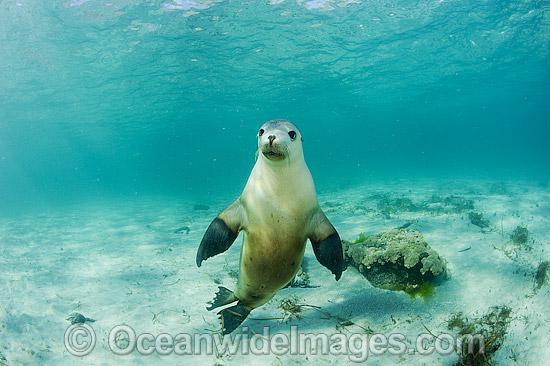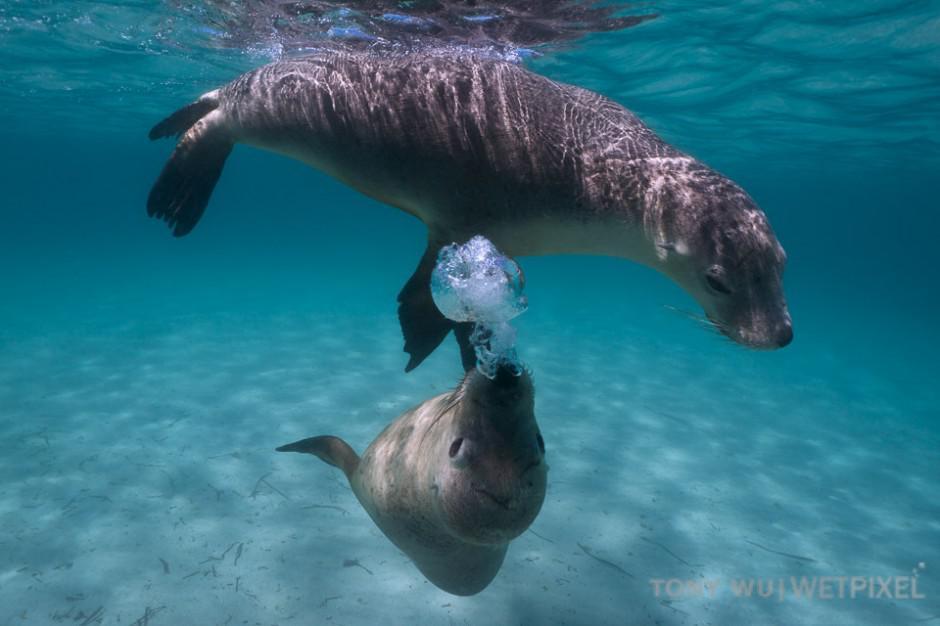The first image is the image on the left, the second image is the image on the right. Analyze the images presented: Is the assertion "None of the images have more than two seals." valid? Answer yes or no. Yes. 